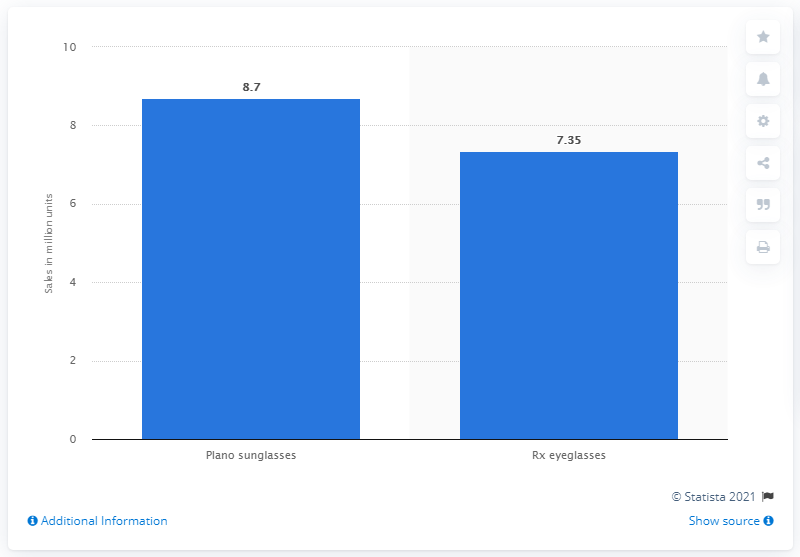Indicate a few pertinent items in this graphic. In 2019, approximately 7.35 pairs of prescription eyeglasses were sold online in the United States. 